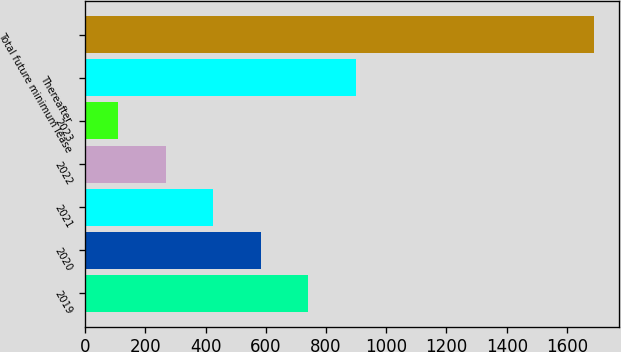Convert chart. <chart><loc_0><loc_0><loc_500><loc_500><bar_chart><fcel>2019<fcel>2020<fcel>2021<fcel>2022<fcel>2023<fcel>Thereafter<fcel>Total future minimum lease<nl><fcel>741.6<fcel>583.7<fcel>425.8<fcel>267.9<fcel>110<fcel>899.5<fcel>1689<nl></chart> 